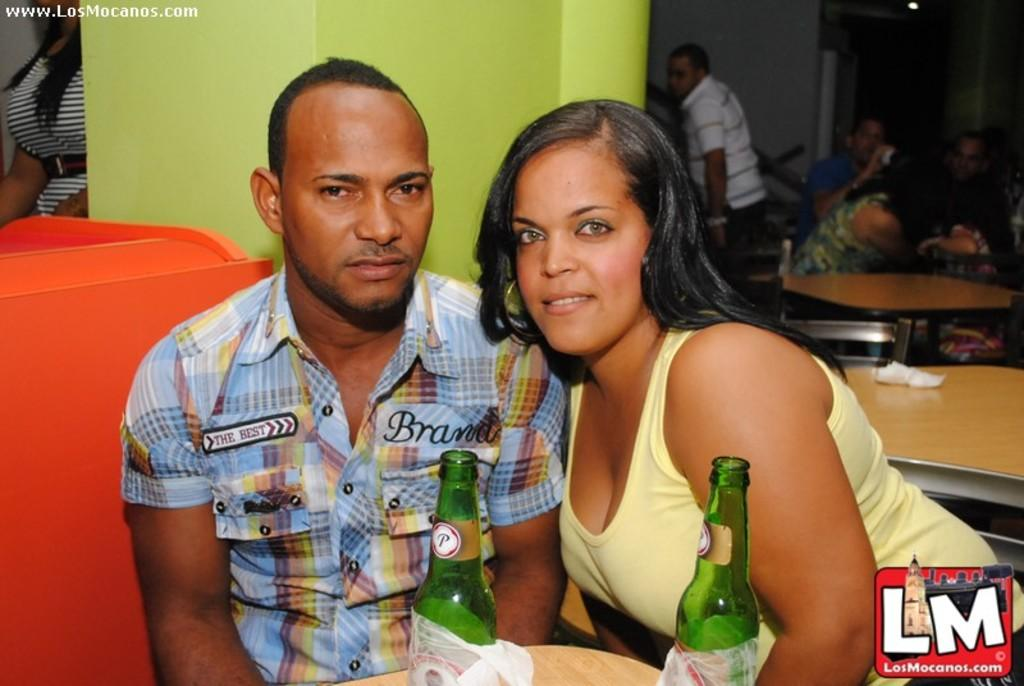Who can be seen in the image? There is a man and a woman in the image. What are the man and woman doing in the image? The man and woman are sitting on chairs. What objects can be seen in the image besides the man and woman? There are bottles, a table, and people visible in the background of the image. What is in the background of the image? There is a wall in the background of the image. How many mice are visible on the table in the image? There are no mice present in the image; the table contains bottles and other items. What type of mitten is the woman wearing in the image? There is: There is no mitten visible in the image; the woman is not wearing any gloves or mittens. 